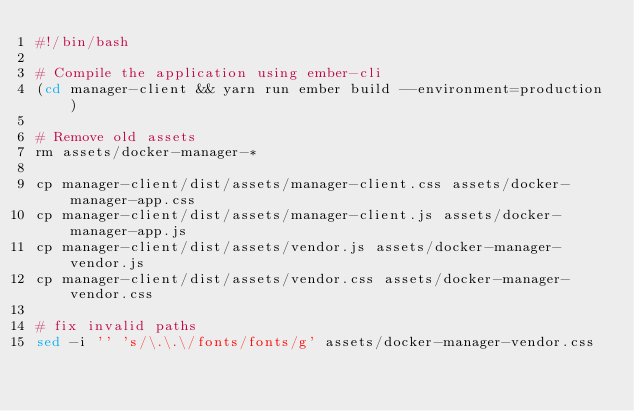Convert code to text. <code><loc_0><loc_0><loc_500><loc_500><_Bash_>#!/bin/bash

# Compile the application using ember-cli
(cd manager-client && yarn run ember build --environment=production)

# Remove old assets
rm assets/docker-manager-*

cp manager-client/dist/assets/manager-client.css assets/docker-manager-app.css
cp manager-client/dist/assets/manager-client.js assets/docker-manager-app.js
cp manager-client/dist/assets/vendor.js assets/docker-manager-vendor.js
cp manager-client/dist/assets/vendor.css assets/docker-manager-vendor.css

# fix invalid paths
sed -i '' 's/\.\.\/fonts/fonts/g' assets/docker-manager-vendor.css
</code> 